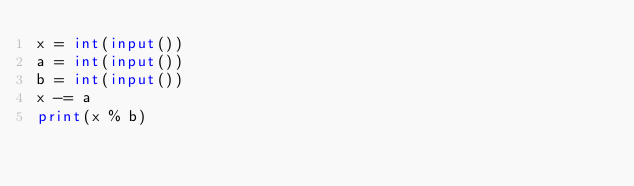Convert code to text. <code><loc_0><loc_0><loc_500><loc_500><_Python_>x = int(input())
a = int(input())
b = int(input())
x -= a
print(x % b)
</code> 